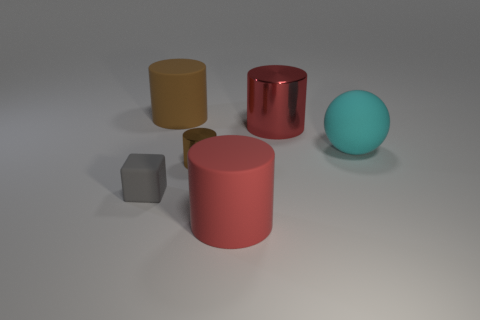What materials do the objects in the image appear to be made of? The objects in the image seem to have varying materials. The cube appears to be made of a solid matte substance. There are two cylinders; the larger one seems metallic and reflective, while the smaller yellow one looks like it could be made of a less reflective material such as plastic. Lastly, the spherical object has a diffuse texture that suggests it could be made of rubber or a matte plastic. 